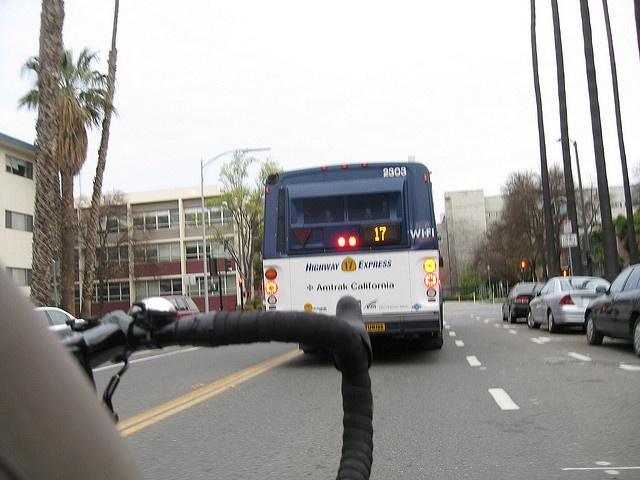Describe the objects in this image and their specific colors. I can see bus in lavender, lightgray, black, and gray tones, bicycle in lavender, black, gray, darkgray, and white tones, people in lavender, gray, and black tones, car in lavender, black, gray, and darkgray tones, and car in lavender, darkgray, gray, lightgray, and black tones in this image. 